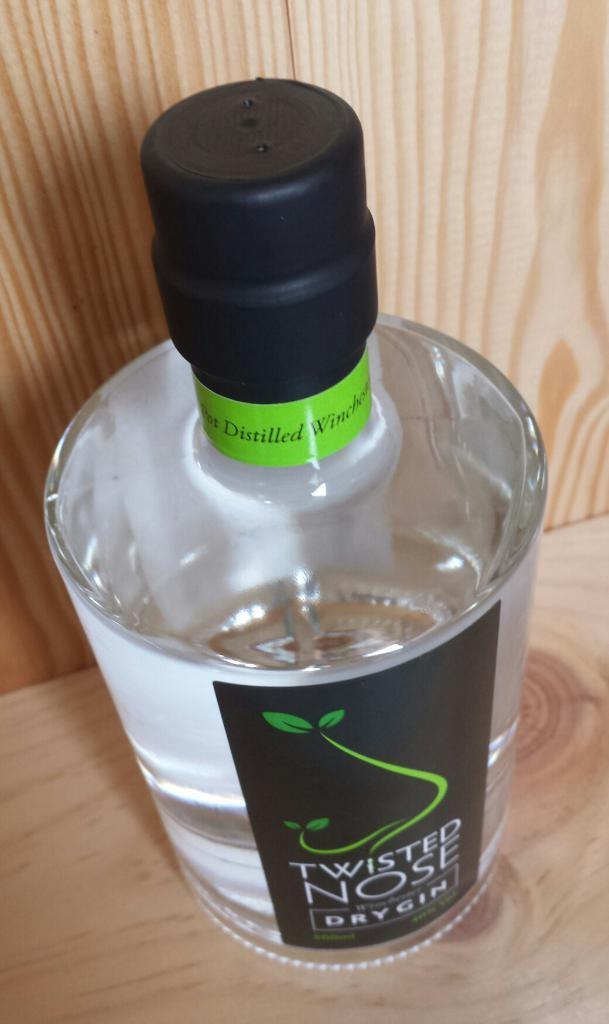<image>
Summarize the visual content of the image. Black sealed top of a bottle with a black label with leaves and white lettering of Twisted Nose Dry Gin 